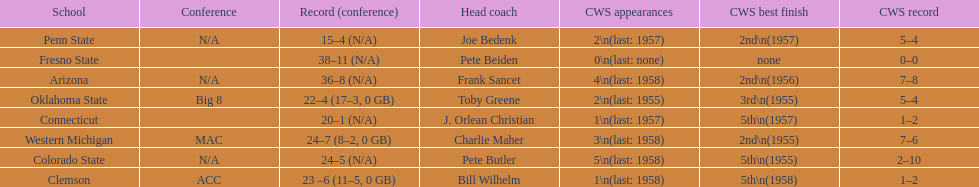I'm looking to parse the entire table for insights. Could you assist me with that? {'header': ['School', 'Conference', 'Record (conference)', 'Head coach', 'CWS appearances', 'CWS best finish', 'CWS record'], 'rows': [['Penn State', 'N/A', '15–4 (N/A)', 'Joe Bedenk', '2\\n(last: 1957)', '2nd\\n(1957)', '5–4'], ['Fresno State', '', '38–11 (N/A)', 'Pete Beiden', '0\\n(last: none)', 'none', '0–0'], ['Arizona', 'N/A', '36–8 (N/A)', 'Frank Sancet', '4\\n(last: 1958)', '2nd\\n(1956)', '7–8'], ['Oklahoma State', 'Big 8', '22–4 (17–3, 0 GB)', 'Toby Greene', '2\\n(last: 1955)', '3rd\\n(1955)', '5–4'], ['Connecticut', '', '20–1 (N/A)', 'J. Orlean Christian', '1\\n(last: 1957)', '5th\\n(1957)', '1–2'], ['Western Michigan', 'MAC', '24–7 (8–2, 0 GB)', 'Charlie Maher', '3\\n(last: 1958)', '2nd\\n(1955)', '7–6'], ['Colorado State', 'N/A', '24–5 (N/A)', 'Pete Butler', '5\\n(last: 1958)', '5th\\n(1955)', '2–10'], ['Clemson', 'ACC', '23 –6 (11–5, 0 GB)', 'Bill Wilhelm', '1\\n(last: 1958)', '5th\\n(1958)', '1–2']]} Which was the only team with less than 20 wins? Penn State. 